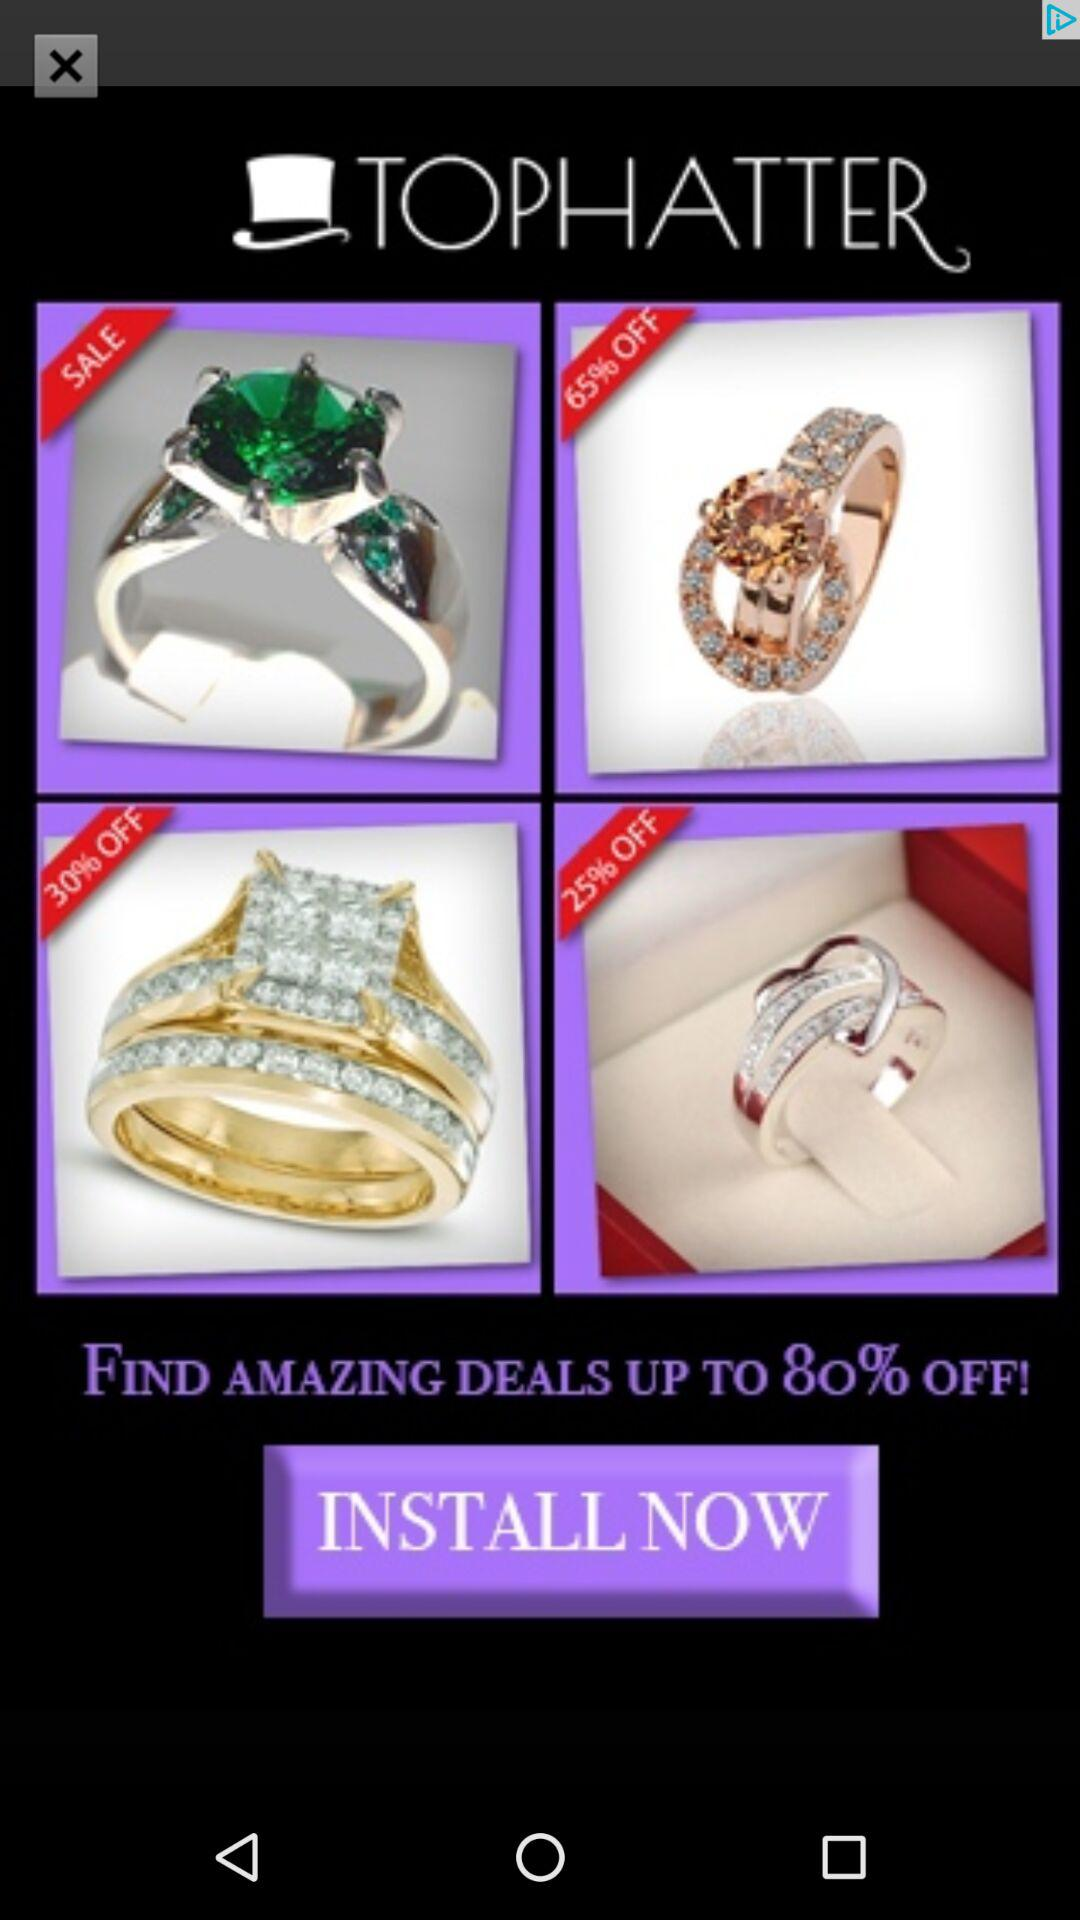How much is the highest discount?
Answer the question using a single word or phrase. 80% 